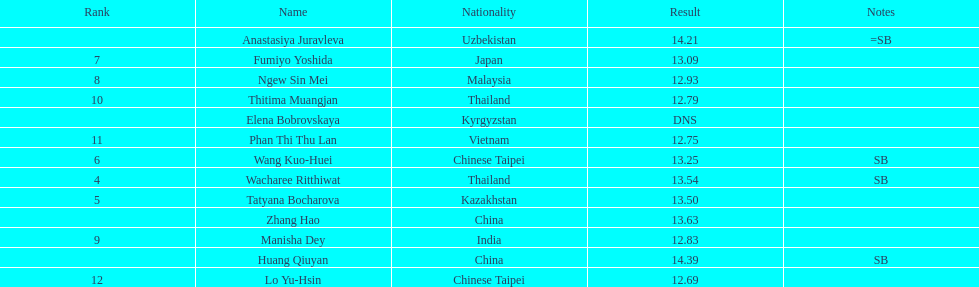How long was manisha dey's jump? 12.83. 